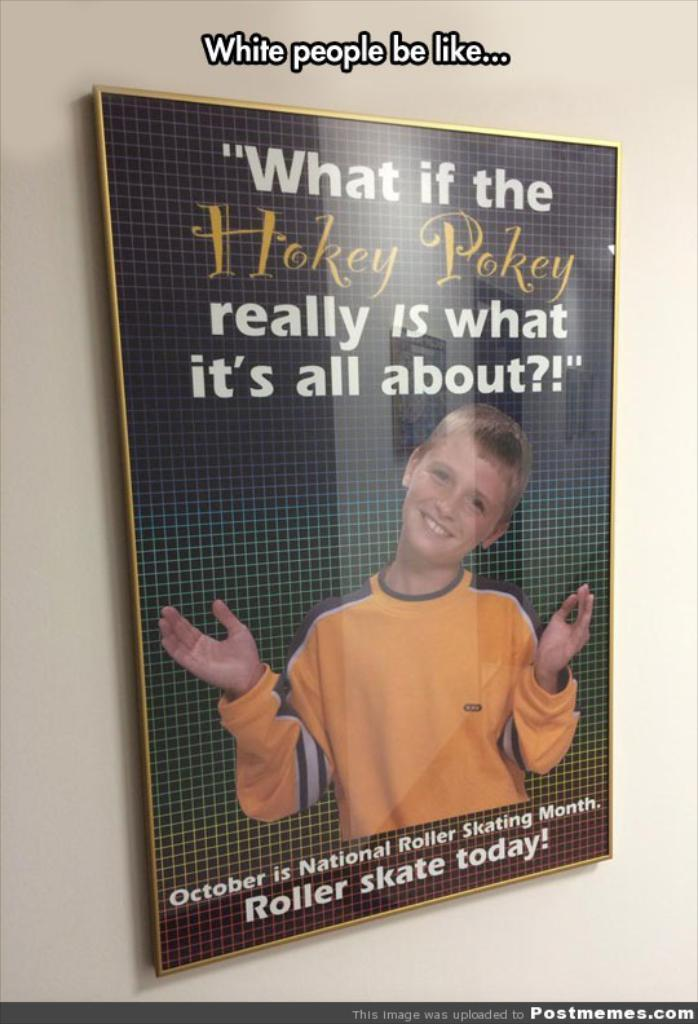<image>
Relay a brief, clear account of the picture shown. According to a poster October is National Roller Skating Month 